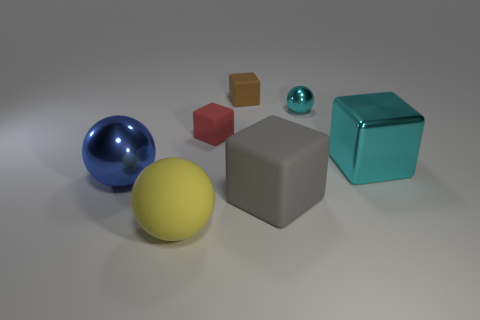Subtract all large spheres. How many spheres are left? 1 Add 2 large gray spheres. How many objects exist? 9 Subtract all blocks. How many objects are left? 3 Subtract all gray cubes. How many cubes are left? 3 Subtract 0 red balls. How many objects are left? 7 Subtract all purple cubes. Subtract all green spheres. How many cubes are left? 4 Subtract all brown cubes. Subtract all cyan metallic objects. How many objects are left? 4 Add 1 small red matte cubes. How many small red matte cubes are left? 2 Add 1 brown cubes. How many brown cubes exist? 2 